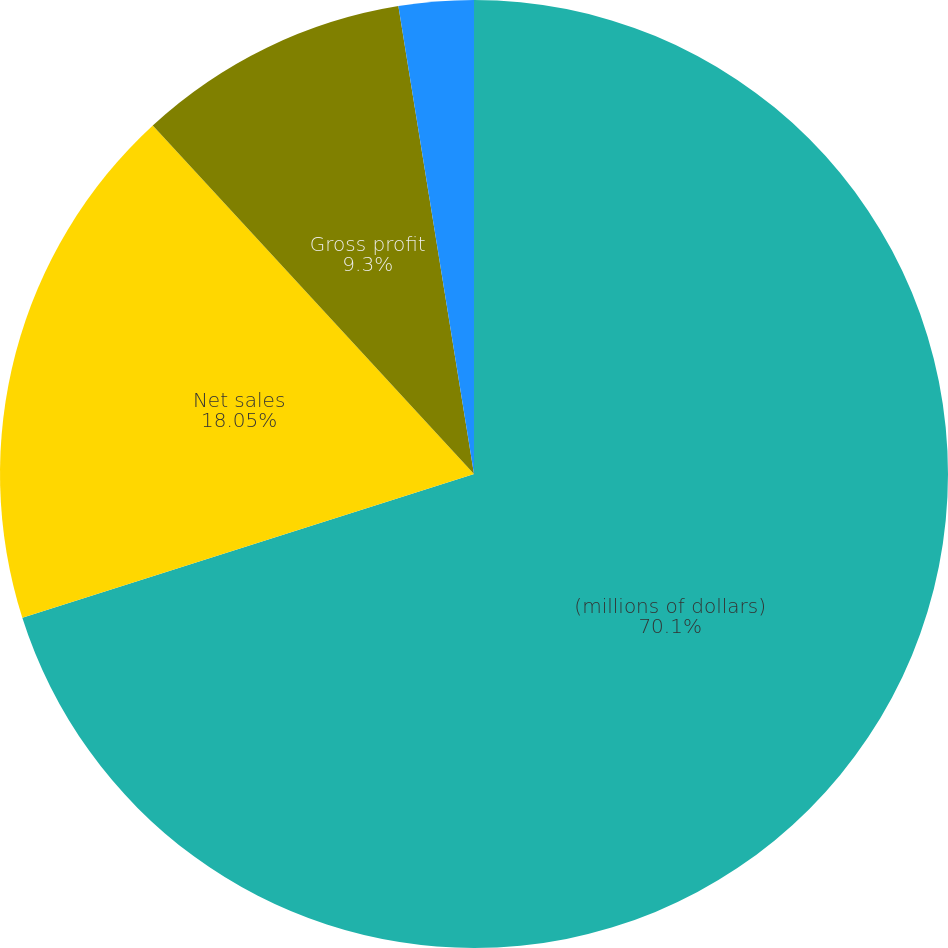<chart> <loc_0><loc_0><loc_500><loc_500><pie_chart><fcel>(millions of dollars)<fcel>Net sales<fcel>Gross profit<fcel>Net earnings<nl><fcel>70.09%<fcel>18.05%<fcel>9.3%<fcel>2.55%<nl></chart> 